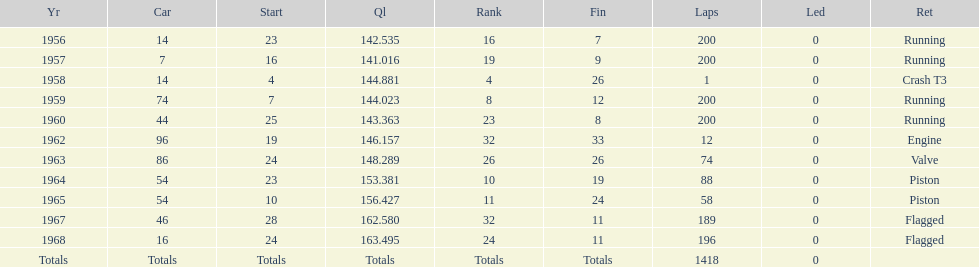How many times was bob veith ranked higher than 10 at an indy 500? 2. 